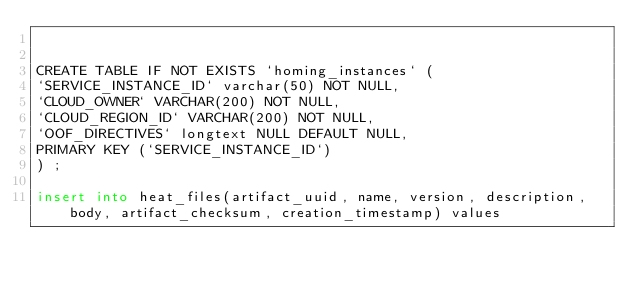<code> <loc_0><loc_0><loc_500><loc_500><_SQL_>

CREATE TABLE IF NOT EXISTS `homing_instances` (
`SERVICE_INSTANCE_ID` varchar(50) NOT NULL,
`CLOUD_OWNER` VARCHAR(200) NOT NULL,
`CLOUD_REGION_ID` VARCHAR(200) NOT NULL,
`OOF_DIRECTIVES` longtext NULL DEFAULT NULL,
PRIMARY KEY (`SERVICE_INSTANCE_ID`)
) ;

insert into heat_files(artifact_uuid, name, version, description, body, artifact_checksum, creation_timestamp) values</code> 